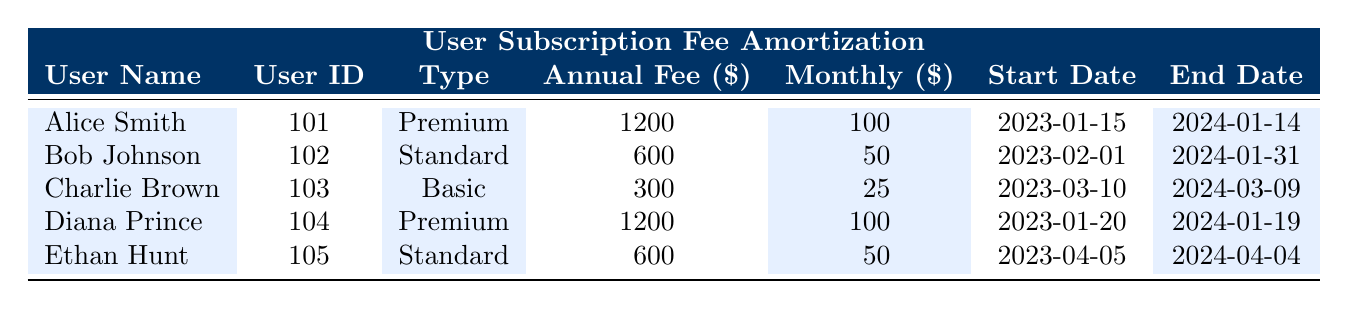What is the annual fee for Alice Smith? From the table, Alice Smith's annual fee is displayed in the column under "Annual Fee ($)". It shows the amount of $1200.
Answer: 1200 How many users have a subscription type of "Standard"? By reviewing the "Type" column, there are two users with the subscription type "Standard": Bob Johnson and Ethan Hunt.
Answer: 2 What is the total monthly amortization for all users combined? To find this, we add the monthly amortization values for each user: 100 + 50 + 25 + 100 + 50 = 325.
Answer: 325 Is Diana Prince’s subscription fee higher than that of Charlie Brown? Diana Prince has an annual fee of $1200, while Charlie Brown has an annual fee of $300. Since 1200 is greater than 300, the statement is true.
Answer: Yes What is the average annual fee for Premium subscription users? There are two Premium users: Alice Smith and Diana Prince, both with an annual fee of $1200 each. The average is (1200 + 1200) / 2 = 1200.
Answer: 1200 For which user does the subscription period last the longest? Charlie Brown has a subscription from 2023-03-10 to 2024-03-09, while others have shorter or the same length subscriptions. Since his subscription is 12 months, we can confirm that.
Answer: Charlie Brown What is the total annual fee collected from Standard subscription users? The annual fees for Standard users: Bob Johnson has $600 and Ethan Hunt has $600. Adding these together gives $600 + $600 = $1200 total annual fee.
Answer: 1200 Is the monthly amortization amount the same for all users? Upon reviewing the "Monthly ($)" column, we see that these amounts differ: 100 for Premium, 50 for Standard, and 25 for Basic. Therefore, the statement is false.
Answer: No How many days does Charlie Brown's subscription last? Charlie Brown's subscription starts on 2023-03-10 and ends on 2024-03-09. That's 364 days total (just one day short of a full year).
Answer: 364 